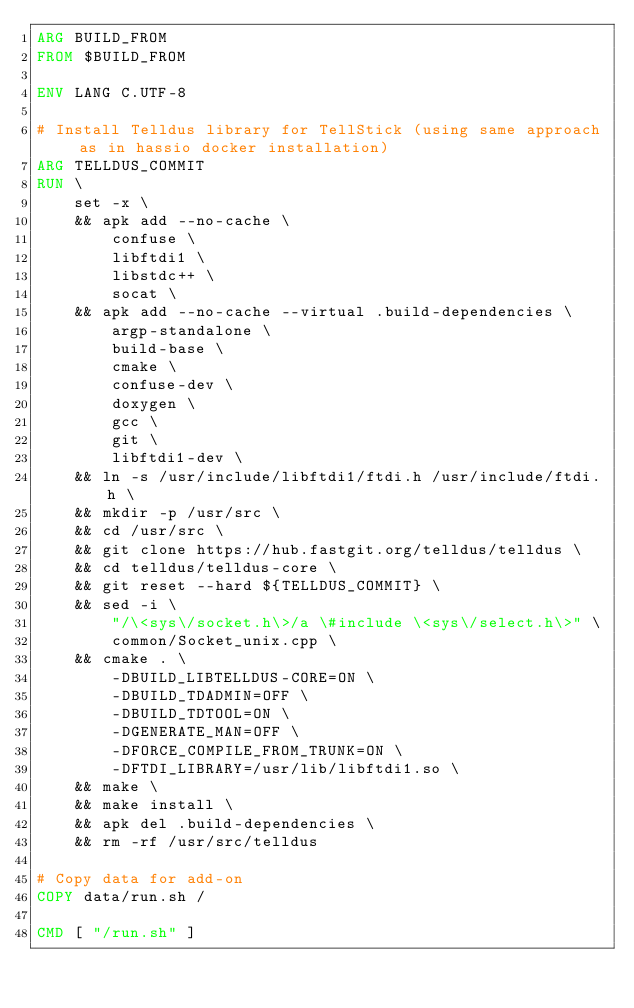Convert code to text. <code><loc_0><loc_0><loc_500><loc_500><_Dockerfile_>ARG BUILD_FROM
FROM $BUILD_FROM

ENV LANG C.UTF-8

# Install Telldus library for TellStick (using same approach as in hassio docker installation)
ARG TELLDUS_COMMIT
RUN \
    set -x \
    && apk add --no-cache \
        confuse \
        libftdi1 \
        libstdc++ \
        socat \
    && apk add --no-cache --virtual .build-dependencies \
        argp-standalone \
        build-base \
        cmake \
        confuse-dev \
        doxygen \
        gcc \
        git \
        libftdi1-dev \
    && ln -s /usr/include/libftdi1/ftdi.h /usr/include/ftdi.h \
    && mkdir -p /usr/src \
    && cd /usr/src \
    && git clone https://hub.fastgit.org/telldus/telldus \
    && cd telldus/telldus-core \
    && git reset --hard ${TELLDUS_COMMIT} \
    && sed -i \
        "/\<sys\/socket.h\>/a \#include \<sys\/select.h\>" \
        common/Socket_unix.cpp \
    && cmake . \
        -DBUILD_LIBTELLDUS-CORE=ON \
        -DBUILD_TDADMIN=OFF \
        -DBUILD_TDTOOL=ON \
        -DGENERATE_MAN=OFF \
        -DFORCE_COMPILE_FROM_TRUNK=ON \
        -DFTDI_LIBRARY=/usr/lib/libftdi1.so \
    && make \
    && make install \
    && apk del .build-dependencies \
    && rm -rf /usr/src/telldus

# Copy data for add-on
COPY data/run.sh /

CMD [ "/run.sh" ]
</code> 